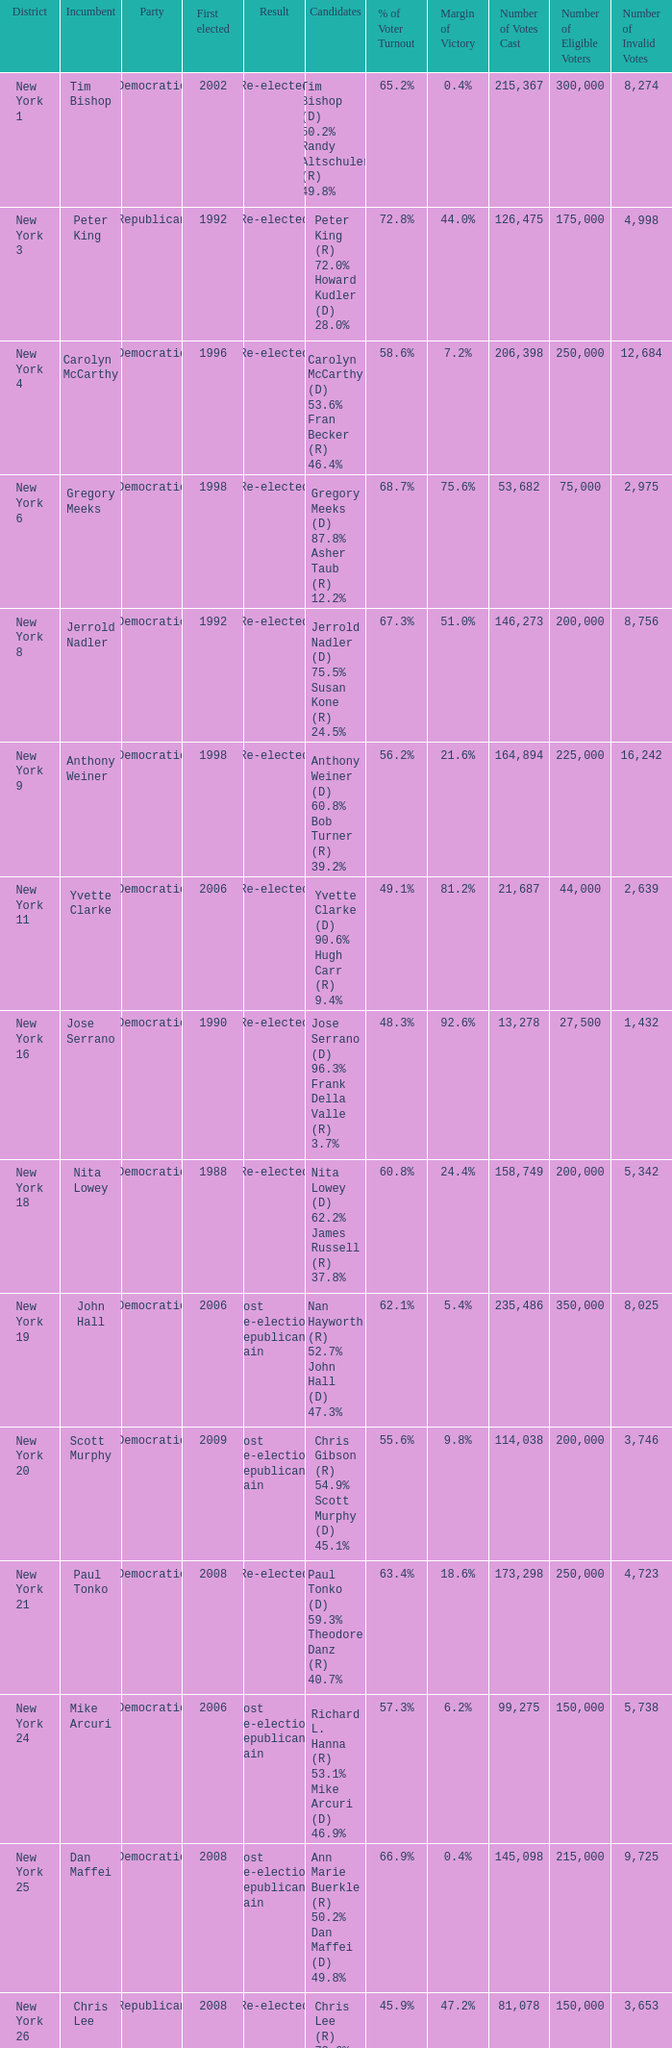Name the result for new york 8 Re-elected. 